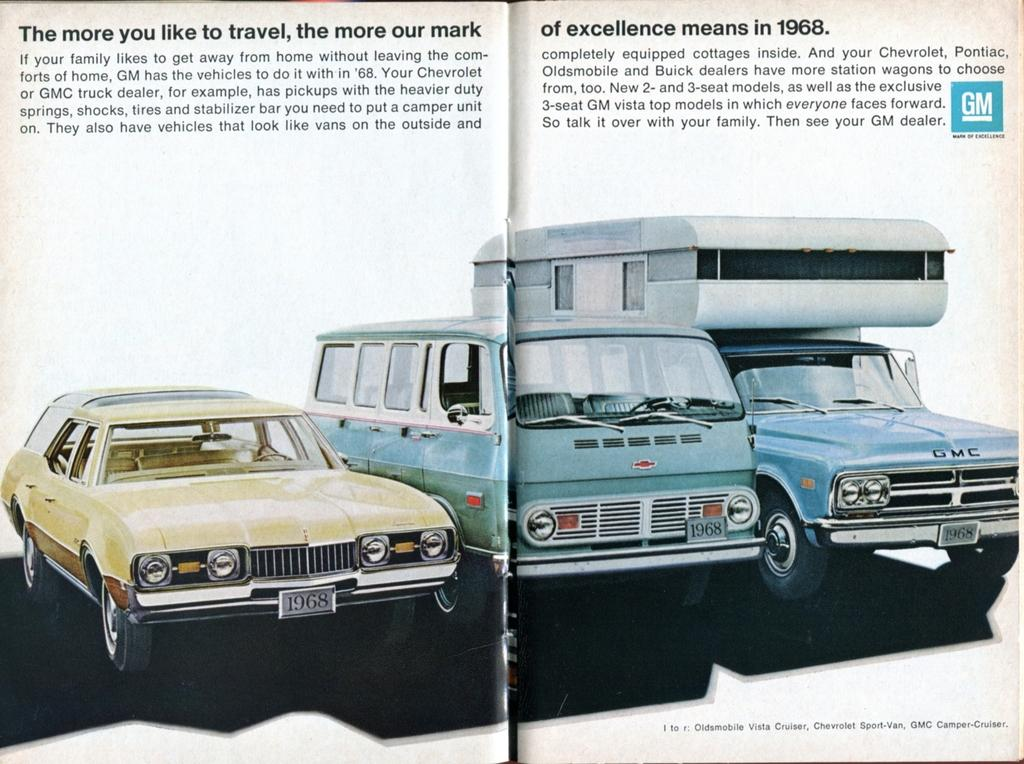<image>
Create a compact narrative representing the image presented. An advertisement for GM vehicles from the year 1968. 